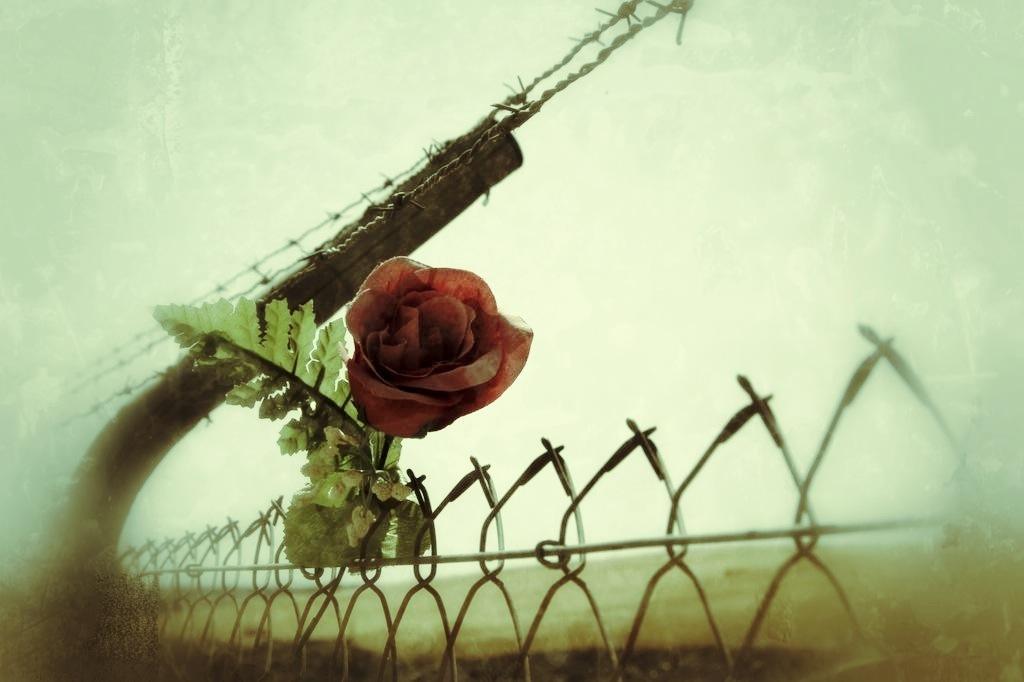Can you describe this image briefly? In this picture we can see a rose flower and leaves, at the bottom there is fence, we can see the sky in the background. 